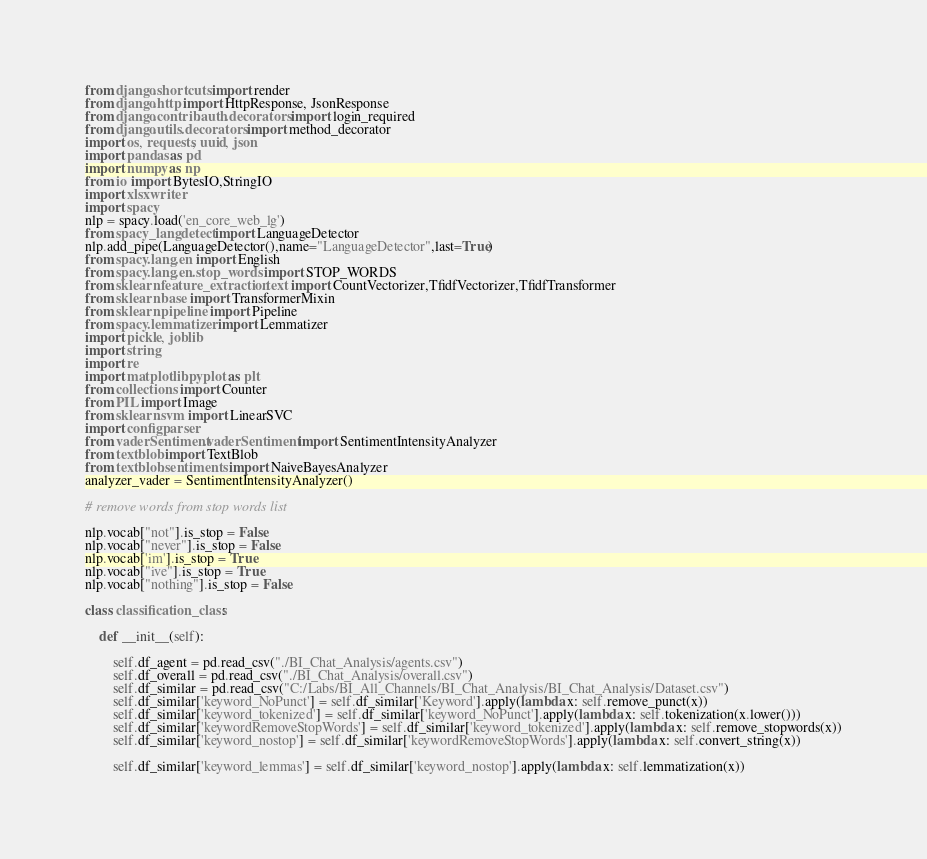<code> <loc_0><loc_0><loc_500><loc_500><_Python_>from django.shortcuts import render
from django.http import HttpResponse, JsonResponse
from django.contrib.auth.decorators import login_required
from django.utils.decorators import method_decorator
import os, requests, uuid, json
import pandas as pd
import numpy as np
from io import BytesIO,StringIO
import xlsxwriter
import spacy
nlp = spacy.load('en_core_web_lg')
from spacy_langdetect import LanguageDetector
nlp.add_pipe(LanguageDetector(),name="LanguageDetector",last=True)
from spacy.lang.en import English
from spacy.lang.en.stop_words import STOP_WORDS
from sklearn.feature_extraction.text import CountVectorizer,TfidfVectorizer,TfidfTransformer
from sklearn.base import TransformerMixin
from sklearn.pipeline import Pipeline
from spacy.lemmatizer import Lemmatizer
import pickle, joblib
import string
import re
import matplotlib.pyplot as plt 
from collections import Counter
from PIL import Image
from sklearn.svm import LinearSVC
import configparser
from vaderSentiment.vaderSentiment import SentimentIntensityAnalyzer
from textblob import TextBlob
from textblob.sentiments import NaiveBayesAnalyzer
analyzer_vader = SentimentIntensityAnalyzer()

# remove words from stop words list

nlp.vocab["not"].is_stop = False
nlp.vocab["never"].is_stop = False
nlp.vocab['im'].is_stop = True
nlp.vocab["ive"].is_stop = True
nlp.vocab["nothing"].is_stop = False

class classification_class:
    
    def __init__(self):
        
        self.df_agent = pd.read_csv("./BI_Chat_Analysis/agents.csv")
        self.df_overall = pd.read_csv("./BI_Chat_Analysis/overall.csv")
        self.df_similar = pd.read_csv("C:/Labs/BI_All_Channels/BI_Chat_Analysis/BI_Chat_Analysis/Dataset.csv")
        self.df_similar['keyword_NoPunct'] = self.df_similar['Keyword'].apply(lambda x: self.remove_punct(x))
        self.df_similar['keyword_tokenized'] = self.df_similar['keyword_NoPunct'].apply(lambda x: self.tokenization(x.lower()))
        self.df_similar['keywordRemoveStopWords'] = self.df_similar['keyword_tokenized'].apply(lambda x: self.remove_stopwords(x))
        self.df_similar['keyword_nostop'] = self.df_similar['keywordRemoveStopWords'].apply(lambda x: self.convert_string(x))

        self.df_similar['keyword_lemmas'] = self.df_similar['keyword_nostop'].apply(lambda x: self.lemmatization(x))
</code> 